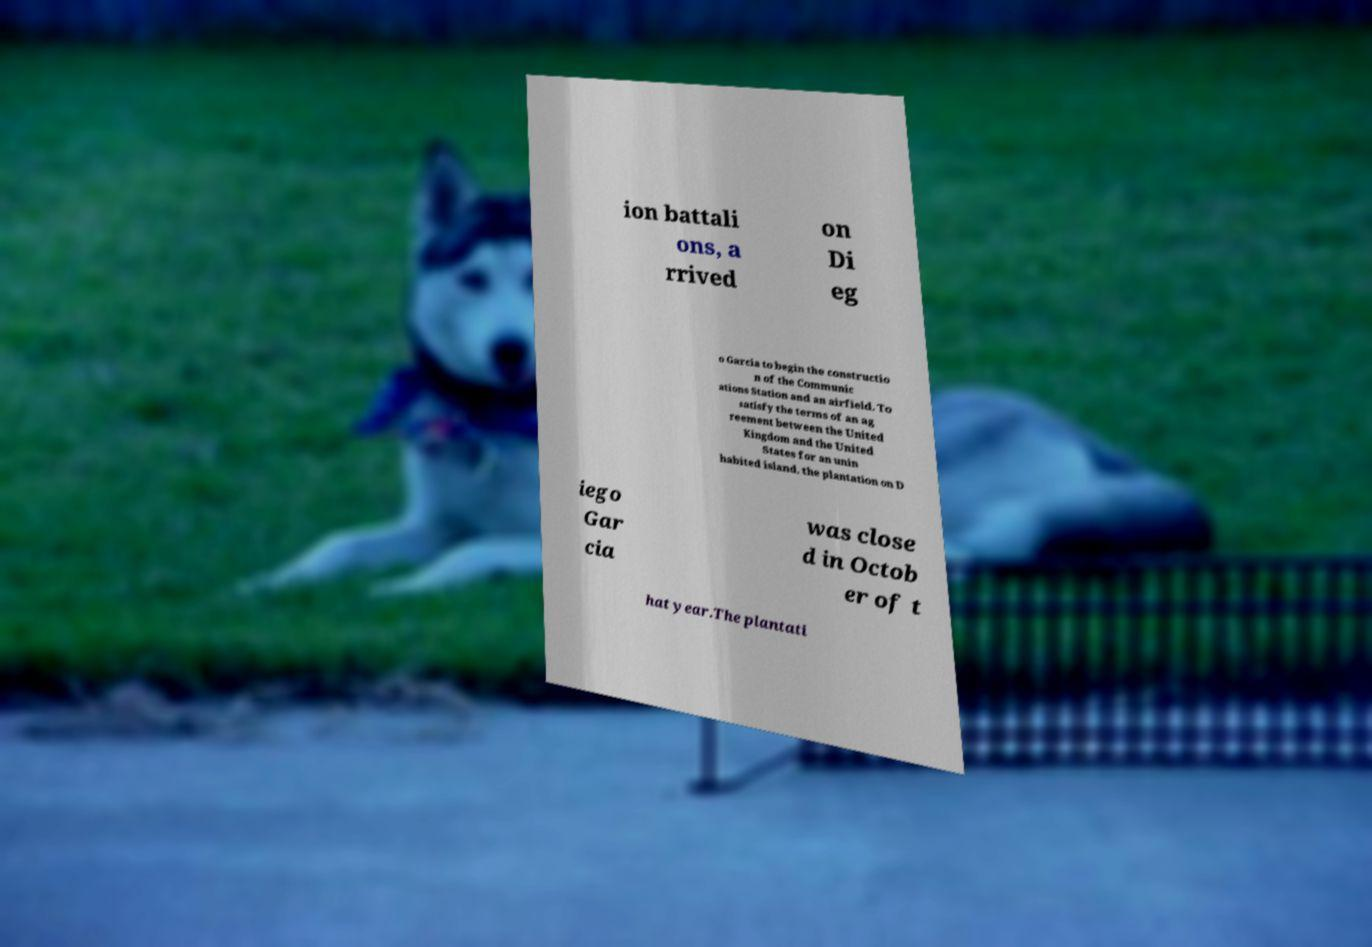Can you read and provide the text displayed in the image?This photo seems to have some interesting text. Can you extract and type it out for me? ion battali ons, a rrived on Di eg o Garcia to begin the constructio n of the Communic ations Station and an airfield. To satisfy the terms of an ag reement between the United Kingdom and the United States for an unin habited island, the plantation on D iego Gar cia was close d in Octob er of t hat year.The plantati 